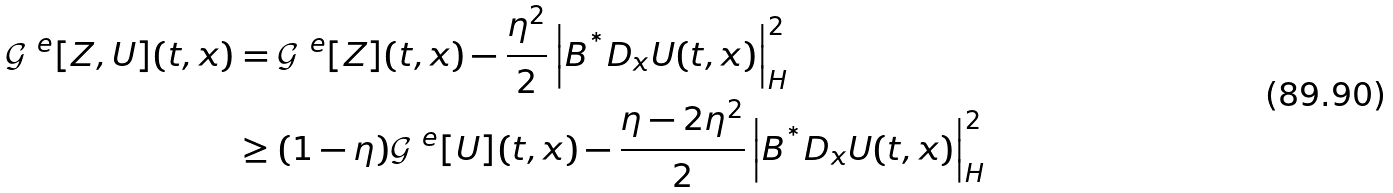Convert formula to latex. <formula><loc_0><loc_0><loc_500><loc_500>\mathcal { G } ^ { \ e } [ Z , U ] ( t , x ) & = \mathcal { G } ^ { \ e } [ Z ] ( t , x ) - \frac { \eta ^ { 2 } } { 2 } \left | B ^ { ^ { * } } D _ { x } U ( t , x ) \right | ^ { 2 } _ { H } \\ & \geq ( 1 - \eta ) \mathcal { G } ^ { \ e } [ U ] ( t , x ) - \frac { \eta - 2 \eta ^ { 2 } } { 2 } \left | B ^ { ^ { * } } D _ { x } U ( t , x ) \right | ^ { 2 } _ { H }</formula> 